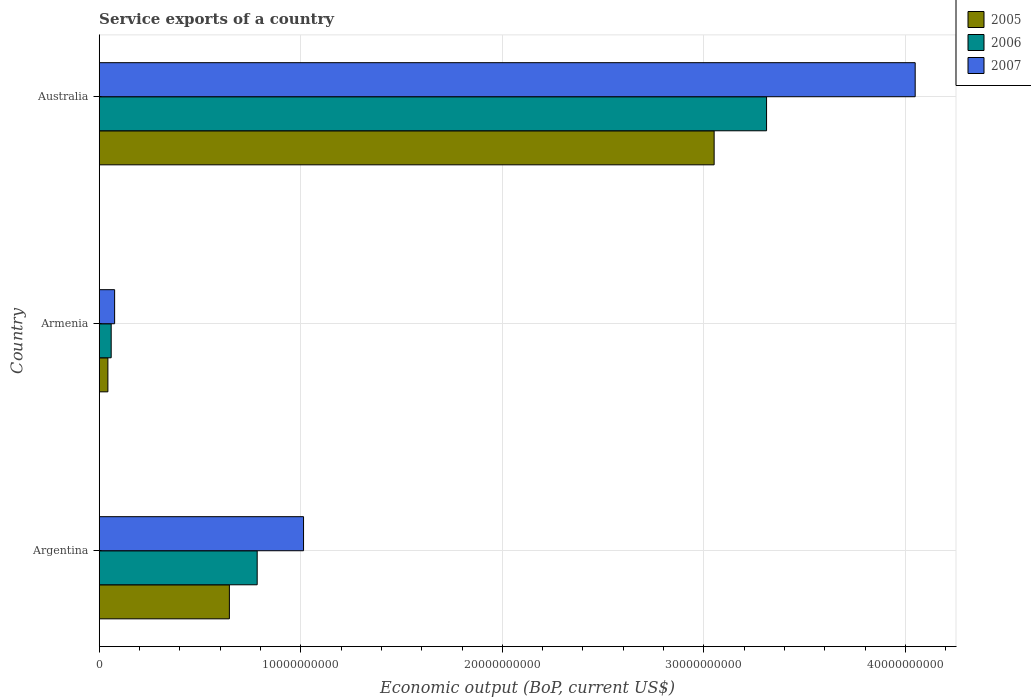How many different coloured bars are there?
Offer a very short reply. 3. How many groups of bars are there?
Make the answer very short. 3. Are the number of bars per tick equal to the number of legend labels?
Provide a short and direct response. Yes. How many bars are there on the 3rd tick from the bottom?
Your answer should be very brief. 3. What is the label of the 3rd group of bars from the top?
Your answer should be very brief. Argentina. In how many cases, is the number of bars for a given country not equal to the number of legend labels?
Provide a short and direct response. 0. What is the service exports in 2006 in Australia?
Your response must be concise. 3.31e+1. Across all countries, what is the maximum service exports in 2005?
Your answer should be very brief. 3.05e+1. Across all countries, what is the minimum service exports in 2007?
Ensure brevity in your answer.  7.64e+08. In which country was the service exports in 2005 maximum?
Your answer should be compact. Australia. In which country was the service exports in 2007 minimum?
Keep it short and to the point. Armenia. What is the total service exports in 2007 in the graph?
Give a very brief answer. 5.14e+1. What is the difference between the service exports in 2006 in Armenia and that in Australia?
Provide a short and direct response. -3.25e+1. What is the difference between the service exports in 2005 in Argentina and the service exports in 2007 in Armenia?
Your response must be concise. 5.69e+09. What is the average service exports in 2007 per country?
Offer a very short reply. 1.71e+1. What is the difference between the service exports in 2006 and service exports in 2005 in Argentina?
Keep it short and to the point. 1.38e+09. What is the ratio of the service exports in 2005 in Armenia to that in Australia?
Offer a very short reply. 0.01. Is the service exports in 2005 in Armenia less than that in Australia?
Your answer should be compact. Yes. Is the difference between the service exports in 2006 in Argentina and Australia greater than the difference between the service exports in 2005 in Argentina and Australia?
Ensure brevity in your answer.  No. What is the difference between the highest and the second highest service exports in 2006?
Make the answer very short. 2.53e+1. What is the difference between the highest and the lowest service exports in 2005?
Give a very brief answer. 3.01e+1. In how many countries, is the service exports in 2007 greater than the average service exports in 2007 taken over all countries?
Provide a succinct answer. 1. Is the sum of the service exports in 2005 in Armenia and Australia greater than the maximum service exports in 2006 across all countries?
Make the answer very short. No. What does the 2nd bar from the top in Armenia represents?
Your answer should be very brief. 2006. What does the 1st bar from the bottom in Argentina represents?
Offer a very short reply. 2005. How many bars are there?
Offer a very short reply. 9. How many countries are there in the graph?
Your answer should be compact. 3. What is the difference between two consecutive major ticks on the X-axis?
Keep it short and to the point. 1.00e+1. Does the graph contain grids?
Provide a succinct answer. Yes. What is the title of the graph?
Provide a succinct answer. Service exports of a country. Does "1965" appear as one of the legend labels in the graph?
Give a very brief answer. No. What is the label or title of the X-axis?
Provide a short and direct response. Economic output (BoP, current US$). What is the Economic output (BoP, current US$) in 2005 in Argentina?
Your answer should be compact. 6.46e+09. What is the Economic output (BoP, current US$) in 2006 in Argentina?
Give a very brief answer. 7.84e+09. What is the Economic output (BoP, current US$) in 2007 in Argentina?
Keep it short and to the point. 1.01e+1. What is the Economic output (BoP, current US$) of 2005 in Armenia?
Make the answer very short. 4.30e+08. What is the Economic output (BoP, current US$) of 2006 in Armenia?
Ensure brevity in your answer.  5.94e+08. What is the Economic output (BoP, current US$) of 2007 in Armenia?
Give a very brief answer. 7.64e+08. What is the Economic output (BoP, current US$) of 2005 in Australia?
Your answer should be very brief. 3.05e+1. What is the Economic output (BoP, current US$) of 2006 in Australia?
Your answer should be very brief. 3.31e+1. What is the Economic output (BoP, current US$) of 2007 in Australia?
Your answer should be compact. 4.05e+1. Across all countries, what is the maximum Economic output (BoP, current US$) of 2005?
Provide a short and direct response. 3.05e+1. Across all countries, what is the maximum Economic output (BoP, current US$) in 2006?
Give a very brief answer. 3.31e+1. Across all countries, what is the maximum Economic output (BoP, current US$) of 2007?
Provide a short and direct response. 4.05e+1. Across all countries, what is the minimum Economic output (BoP, current US$) in 2005?
Your answer should be very brief. 4.30e+08. Across all countries, what is the minimum Economic output (BoP, current US$) in 2006?
Your answer should be compact. 5.94e+08. Across all countries, what is the minimum Economic output (BoP, current US$) in 2007?
Provide a short and direct response. 7.64e+08. What is the total Economic output (BoP, current US$) in 2005 in the graph?
Your response must be concise. 3.74e+1. What is the total Economic output (BoP, current US$) in 2006 in the graph?
Provide a succinct answer. 4.15e+1. What is the total Economic output (BoP, current US$) of 2007 in the graph?
Keep it short and to the point. 5.14e+1. What is the difference between the Economic output (BoP, current US$) of 2005 in Argentina and that in Armenia?
Your answer should be compact. 6.03e+09. What is the difference between the Economic output (BoP, current US$) in 2006 in Argentina and that in Armenia?
Offer a terse response. 7.24e+09. What is the difference between the Economic output (BoP, current US$) in 2007 in Argentina and that in Armenia?
Keep it short and to the point. 9.37e+09. What is the difference between the Economic output (BoP, current US$) in 2005 in Argentina and that in Australia?
Your answer should be very brief. -2.40e+1. What is the difference between the Economic output (BoP, current US$) of 2006 in Argentina and that in Australia?
Make the answer very short. -2.53e+1. What is the difference between the Economic output (BoP, current US$) of 2007 in Argentina and that in Australia?
Give a very brief answer. -3.03e+1. What is the difference between the Economic output (BoP, current US$) of 2005 in Armenia and that in Australia?
Your response must be concise. -3.01e+1. What is the difference between the Economic output (BoP, current US$) of 2006 in Armenia and that in Australia?
Offer a terse response. -3.25e+1. What is the difference between the Economic output (BoP, current US$) of 2007 in Armenia and that in Australia?
Provide a succinct answer. -3.97e+1. What is the difference between the Economic output (BoP, current US$) of 2005 in Argentina and the Economic output (BoP, current US$) of 2006 in Armenia?
Your answer should be compact. 5.86e+09. What is the difference between the Economic output (BoP, current US$) in 2005 in Argentina and the Economic output (BoP, current US$) in 2007 in Armenia?
Keep it short and to the point. 5.69e+09. What is the difference between the Economic output (BoP, current US$) in 2006 in Argentina and the Economic output (BoP, current US$) in 2007 in Armenia?
Your response must be concise. 7.07e+09. What is the difference between the Economic output (BoP, current US$) of 2005 in Argentina and the Economic output (BoP, current US$) of 2006 in Australia?
Ensure brevity in your answer.  -2.66e+1. What is the difference between the Economic output (BoP, current US$) in 2005 in Argentina and the Economic output (BoP, current US$) in 2007 in Australia?
Your answer should be very brief. -3.40e+1. What is the difference between the Economic output (BoP, current US$) in 2006 in Argentina and the Economic output (BoP, current US$) in 2007 in Australia?
Provide a short and direct response. -3.26e+1. What is the difference between the Economic output (BoP, current US$) of 2005 in Armenia and the Economic output (BoP, current US$) of 2006 in Australia?
Offer a terse response. -3.27e+1. What is the difference between the Economic output (BoP, current US$) in 2005 in Armenia and the Economic output (BoP, current US$) in 2007 in Australia?
Your answer should be very brief. -4.01e+1. What is the difference between the Economic output (BoP, current US$) in 2006 in Armenia and the Economic output (BoP, current US$) in 2007 in Australia?
Provide a short and direct response. -3.99e+1. What is the average Economic output (BoP, current US$) of 2005 per country?
Make the answer very short. 1.25e+1. What is the average Economic output (BoP, current US$) in 2006 per country?
Offer a terse response. 1.38e+1. What is the average Economic output (BoP, current US$) in 2007 per country?
Provide a succinct answer. 1.71e+1. What is the difference between the Economic output (BoP, current US$) in 2005 and Economic output (BoP, current US$) in 2006 in Argentina?
Make the answer very short. -1.38e+09. What is the difference between the Economic output (BoP, current US$) in 2005 and Economic output (BoP, current US$) in 2007 in Argentina?
Ensure brevity in your answer.  -3.68e+09. What is the difference between the Economic output (BoP, current US$) in 2006 and Economic output (BoP, current US$) in 2007 in Argentina?
Keep it short and to the point. -2.30e+09. What is the difference between the Economic output (BoP, current US$) in 2005 and Economic output (BoP, current US$) in 2006 in Armenia?
Provide a succinct answer. -1.64e+08. What is the difference between the Economic output (BoP, current US$) of 2005 and Economic output (BoP, current US$) of 2007 in Armenia?
Provide a succinct answer. -3.34e+08. What is the difference between the Economic output (BoP, current US$) in 2006 and Economic output (BoP, current US$) in 2007 in Armenia?
Make the answer very short. -1.70e+08. What is the difference between the Economic output (BoP, current US$) of 2005 and Economic output (BoP, current US$) of 2006 in Australia?
Your response must be concise. -2.60e+09. What is the difference between the Economic output (BoP, current US$) in 2005 and Economic output (BoP, current US$) in 2007 in Australia?
Offer a terse response. -9.97e+09. What is the difference between the Economic output (BoP, current US$) in 2006 and Economic output (BoP, current US$) in 2007 in Australia?
Your answer should be compact. -7.37e+09. What is the ratio of the Economic output (BoP, current US$) of 2005 in Argentina to that in Armenia?
Your answer should be compact. 15.01. What is the ratio of the Economic output (BoP, current US$) in 2006 in Argentina to that in Armenia?
Ensure brevity in your answer.  13.2. What is the ratio of the Economic output (BoP, current US$) of 2007 in Argentina to that in Armenia?
Make the answer very short. 13.26. What is the ratio of the Economic output (BoP, current US$) of 2005 in Argentina to that in Australia?
Provide a short and direct response. 0.21. What is the ratio of the Economic output (BoP, current US$) in 2006 in Argentina to that in Australia?
Provide a short and direct response. 0.24. What is the ratio of the Economic output (BoP, current US$) in 2007 in Argentina to that in Australia?
Provide a succinct answer. 0.25. What is the ratio of the Economic output (BoP, current US$) in 2005 in Armenia to that in Australia?
Your answer should be compact. 0.01. What is the ratio of the Economic output (BoP, current US$) of 2006 in Armenia to that in Australia?
Keep it short and to the point. 0.02. What is the ratio of the Economic output (BoP, current US$) in 2007 in Armenia to that in Australia?
Give a very brief answer. 0.02. What is the difference between the highest and the second highest Economic output (BoP, current US$) of 2005?
Offer a very short reply. 2.40e+1. What is the difference between the highest and the second highest Economic output (BoP, current US$) of 2006?
Your answer should be very brief. 2.53e+1. What is the difference between the highest and the second highest Economic output (BoP, current US$) in 2007?
Keep it short and to the point. 3.03e+1. What is the difference between the highest and the lowest Economic output (BoP, current US$) in 2005?
Give a very brief answer. 3.01e+1. What is the difference between the highest and the lowest Economic output (BoP, current US$) of 2006?
Your response must be concise. 3.25e+1. What is the difference between the highest and the lowest Economic output (BoP, current US$) in 2007?
Make the answer very short. 3.97e+1. 